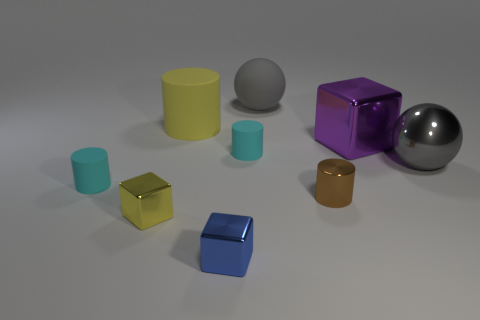Subtract all cubes. How many objects are left? 6 Add 2 big red blocks. How many big red blocks exist? 2 Subtract 0 yellow balls. How many objects are left? 9 Subtract all small metallic cylinders. Subtract all tiny metal cylinders. How many objects are left? 7 Add 5 metal blocks. How many metal blocks are left? 8 